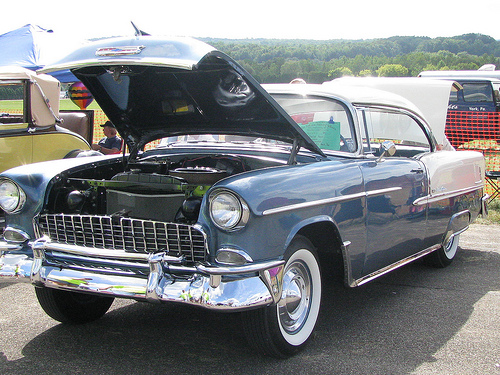<image>
Is there a car next to the sky? No. The car is not positioned next to the sky. They are located in different areas of the scene. 